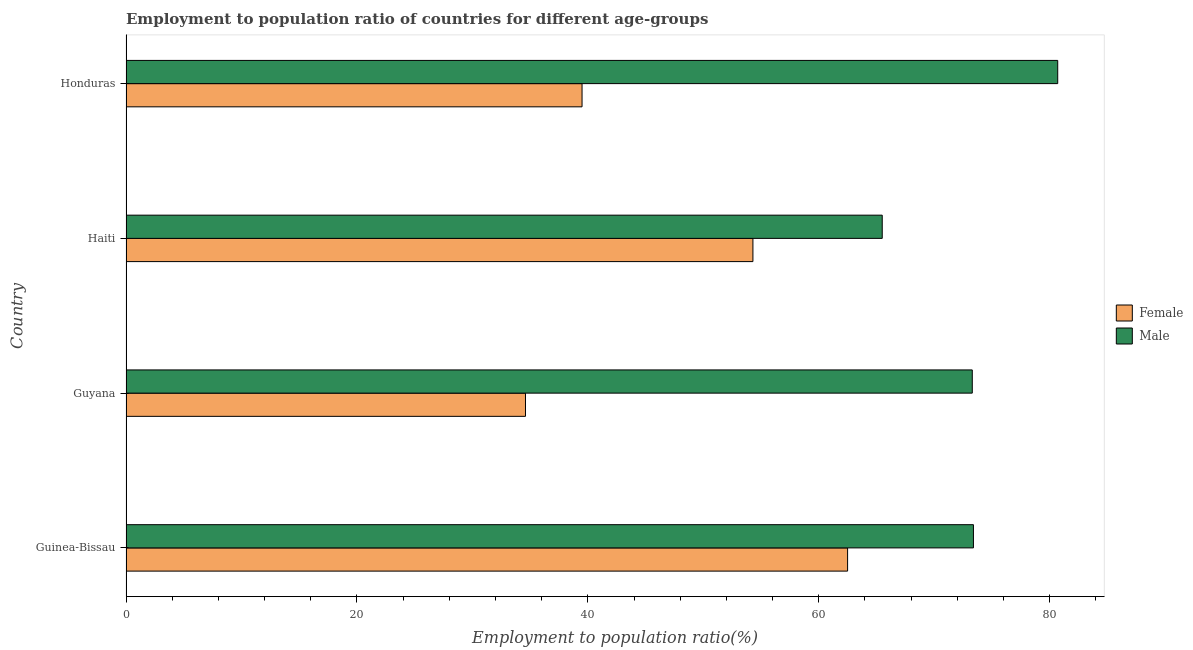How many different coloured bars are there?
Ensure brevity in your answer.  2. How many groups of bars are there?
Offer a terse response. 4. Are the number of bars per tick equal to the number of legend labels?
Make the answer very short. Yes. Are the number of bars on each tick of the Y-axis equal?
Ensure brevity in your answer.  Yes. How many bars are there on the 3rd tick from the bottom?
Your answer should be compact. 2. What is the label of the 1st group of bars from the top?
Provide a succinct answer. Honduras. In how many cases, is the number of bars for a given country not equal to the number of legend labels?
Offer a very short reply. 0. What is the employment to population ratio(female) in Guinea-Bissau?
Make the answer very short. 62.5. Across all countries, what is the maximum employment to population ratio(male)?
Keep it short and to the point. 80.7. Across all countries, what is the minimum employment to population ratio(male)?
Offer a very short reply. 65.5. In which country was the employment to population ratio(female) maximum?
Offer a very short reply. Guinea-Bissau. In which country was the employment to population ratio(female) minimum?
Provide a short and direct response. Guyana. What is the total employment to population ratio(male) in the graph?
Offer a very short reply. 292.9. What is the difference between the employment to population ratio(male) in Guinea-Bissau and that in Haiti?
Your answer should be compact. 7.9. What is the difference between the employment to population ratio(male) in Guyana and the employment to population ratio(female) in Haiti?
Offer a very short reply. 19. What is the average employment to population ratio(female) per country?
Provide a succinct answer. 47.73. What is the ratio of the employment to population ratio(female) in Guinea-Bissau to that in Honduras?
Keep it short and to the point. 1.58. Is the employment to population ratio(female) in Guinea-Bissau less than that in Honduras?
Your answer should be very brief. No. Is the difference between the employment to population ratio(female) in Guinea-Bissau and Guyana greater than the difference between the employment to population ratio(male) in Guinea-Bissau and Guyana?
Provide a short and direct response. Yes. What is the difference between the highest and the second highest employment to population ratio(male)?
Provide a short and direct response. 7.3. What is the difference between the highest and the lowest employment to population ratio(female)?
Make the answer very short. 27.9. Is the sum of the employment to population ratio(female) in Guinea-Bissau and Honduras greater than the maximum employment to population ratio(male) across all countries?
Give a very brief answer. Yes. What does the 1st bar from the top in Guyana represents?
Provide a short and direct response. Male. What does the 1st bar from the bottom in Haiti represents?
Ensure brevity in your answer.  Female. What is the difference between two consecutive major ticks on the X-axis?
Your answer should be very brief. 20. How many legend labels are there?
Make the answer very short. 2. What is the title of the graph?
Your answer should be very brief. Employment to population ratio of countries for different age-groups. Does "Export" appear as one of the legend labels in the graph?
Keep it short and to the point. No. What is the label or title of the X-axis?
Your answer should be compact. Employment to population ratio(%). What is the Employment to population ratio(%) in Female in Guinea-Bissau?
Ensure brevity in your answer.  62.5. What is the Employment to population ratio(%) in Male in Guinea-Bissau?
Ensure brevity in your answer.  73.4. What is the Employment to population ratio(%) of Female in Guyana?
Your response must be concise. 34.6. What is the Employment to population ratio(%) in Male in Guyana?
Ensure brevity in your answer.  73.3. What is the Employment to population ratio(%) of Female in Haiti?
Your answer should be compact. 54.3. What is the Employment to population ratio(%) in Male in Haiti?
Your answer should be very brief. 65.5. What is the Employment to population ratio(%) of Female in Honduras?
Your answer should be very brief. 39.5. What is the Employment to population ratio(%) of Male in Honduras?
Offer a very short reply. 80.7. Across all countries, what is the maximum Employment to population ratio(%) of Female?
Offer a terse response. 62.5. Across all countries, what is the maximum Employment to population ratio(%) of Male?
Give a very brief answer. 80.7. Across all countries, what is the minimum Employment to population ratio(%) of Female?
Your response must be concise. 34.6. Across all countries, what is the minimum Employment to population ratio(%) in Male?
Ensure brevity in your answer.  65.5. What is the total Employment to population ratio(%) in Female in the graph?
Offer a terse response. 190.9. What is the total Employment to population ratio(%) of Male in the graph?
Keep it short and to the point. 292.9. What is the difference between the Employment to population ratio(%) of Female in Guinea-Bissau and that in Guyana?
Offer a very short reply. 27.9. What is the difference between the Employment to population ratio(%) in Male in Guinea-Bissau and that in Guyana?
Keep it short and to the point. 0.1. What is the difference between the Employment to population ratio(%) of Female in Guinea-Bissau and that in Haiti?
Make the answer very short. 8.2. What is the difference between the Employment to population ratio(%) of Male in Guinea-Bissau and that in Haiti?
Keep it short and to the point. 7.9. What is the difference between the Employment to population ratio(%) in Female in Guinea-Bissau and that in Honduras?
Give a very brief answer. 23. What is the difference between the Employment to population ratio(%) of Female in Guyana and that in Haiti?
Your answer should be very brief. -19.7. What is the difference between the Employment to population ratio(%) of Male in Guyana and that in Haiti?
Provide a succinct answer. 7.8. What is the difference between the Employment to population ratio(%) of Female in Guyana and that in Honduras?
Give a very brief answer. -4.9. What is the difference between the Employment to population ratio(%) of Male in Haiti and that in Honduras?
Offer a terse response. -15.2. What is the difference between the Employment to population ratio(%) of Female in Guinea-Bissau and the Employment to population ratio(%) of Male in Haiti?
Your answer should be compact. -3. What is the difference between the Employment to population ratio(%) in Female in Guinea-Bissau and the Employment to population ratio(%) in Male in Honduras?
Your answer should be compact. -18.2. What is the difference between the Employment to population ratio(%) in Female in Guyana and the Employment to population ratio(%) in Male in Haiti?
Ensure brevity in your answer.  -30.9. What is the difference between the Employment to population ratio(%) of Female in Guyana and the Employment to population ratio(%) of Male in Honduras?
Provide a short and direct response. -46.1. What is the difference between the Employment to population ratio(%) in Female in Haiti and the Employment to population ratio(%) in Male in Honduras?
Ensure brevity in your answer.  -26.4. What is the average Employment to population ratio(%) in Female per country?
Make the answer very short. 47.73. What is the average Employment to population ratio(%) in Male per country?
Provide a short and direct response. 73.22. What is the difference between the Employment to population ratio(%) in Female and Employment to population ratio(%) in Male in Guyana?
Provide a succinct answer. -38.7. What is the difference between the Employment to population ratio(%) in Female and Employment to population ratio(%) in Male in Honduras?
Ensure brevity in your answer.  -41.2. What is the ratio of the Employment to population ratio(%) of Female in Guinea-Bissau to that in Guyana?
Ensure brevity in your answer.  1.81. What is the ratio of the Employment to population ratio(%) in Female in Guinea-Bissau to that in Haiti?
Your answer should be compact. 1.15. What is the ratio of the Employment to population ratio(%) of Male in Guinea-Bissau to that in Haiti?
Provide a short and direct response. 1.12. What is the ratio of the Employment to population ratio(%) of Female in Guinea-Bissau to that in Honduras?
Your response must be concise. 1.58. What is the ratio of the Employment to population ratio(%) in Male in Guinea-Bissau to that in Honduras?
Give a very brief answer. 0.91. What is the ratio of the Employment to population ratio(%) in Female in Guyana to that in Haiti?
Make the answer very short. 0.64. What is the ratio of the Employment to population ratio(%) in Male in Guyana to that in Haiti?
Provide a short and direct response. 1.12. What is the ratio of the Employment to population ratio(%) of Female in Guyana to that in Honduras?
Keep it short and to the point. 0.88. What is the ratio of the Employment to population ratio(%) of Male in Guyana to that in Honduras?
Your response must be concise. 0.91. What is the ratio of the Employment to population ratio(%) of Female in Haiti to that in Honduras?
Your answer should be compact. 1.37. What is the ratio of the Employment to population ratio(%) of Male in Haiti to that in Honduras?
Provide a short and direct response. 0.81. What is the difference between the highest and the second highest Employment to population ratio(%) of Male?
Make the answer very short. 7.3. What is the difference between the highest and the lowest Employment to population ratio(%) in Female?
Provide a short and direct response. 27.9. 